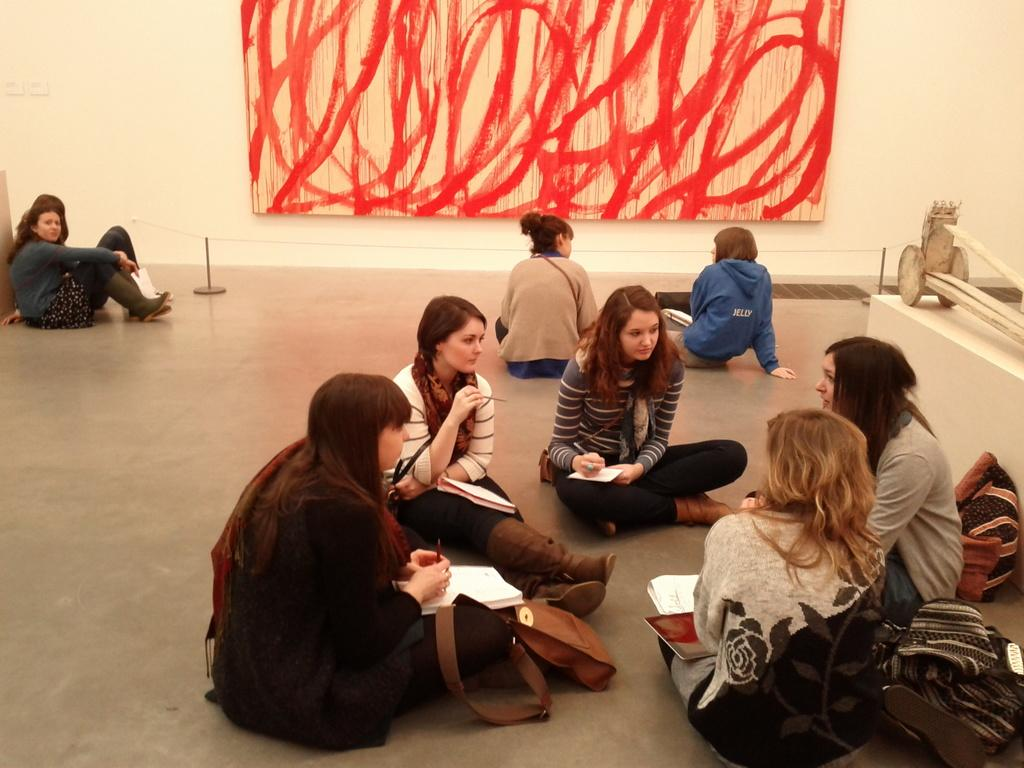What are the people in the image doing? The people in the image are sitting and holding books. What objects can be seen on the floor in the image? There are bags placed on the floor in the image. What can be seen in the background of the image? There is a curtain and a wall in the background of the image. What type of cars can be seen driving on the island in the image? There are no cars or islands present in the image; it features people sitting and holding books, with bags on the floor, and a curtain and wall in the background. 